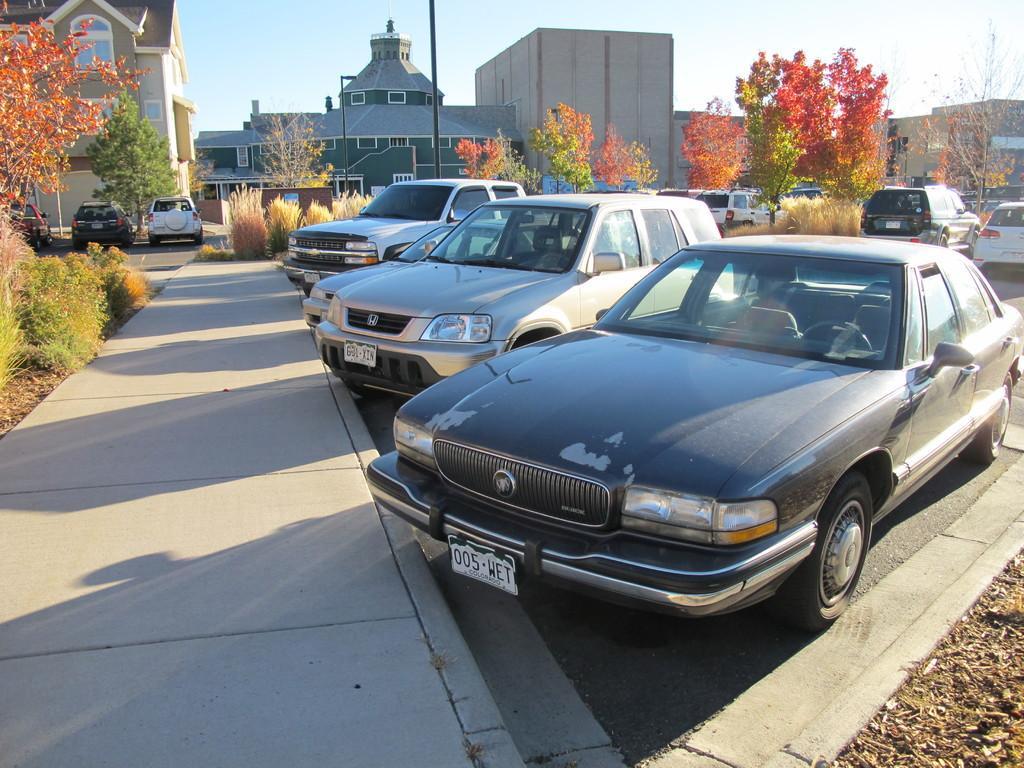How would you summarize this image in a sentence or two? Here we can see a number of vehicles, trees and plants. Background there are buildings with windows and black pole. 